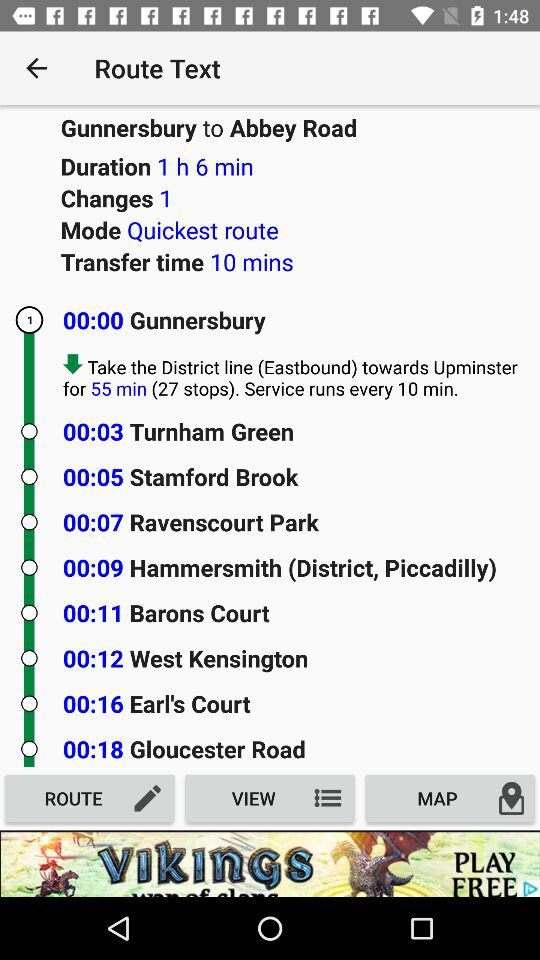What mode is applied? The applied mode is "Quickest route". 